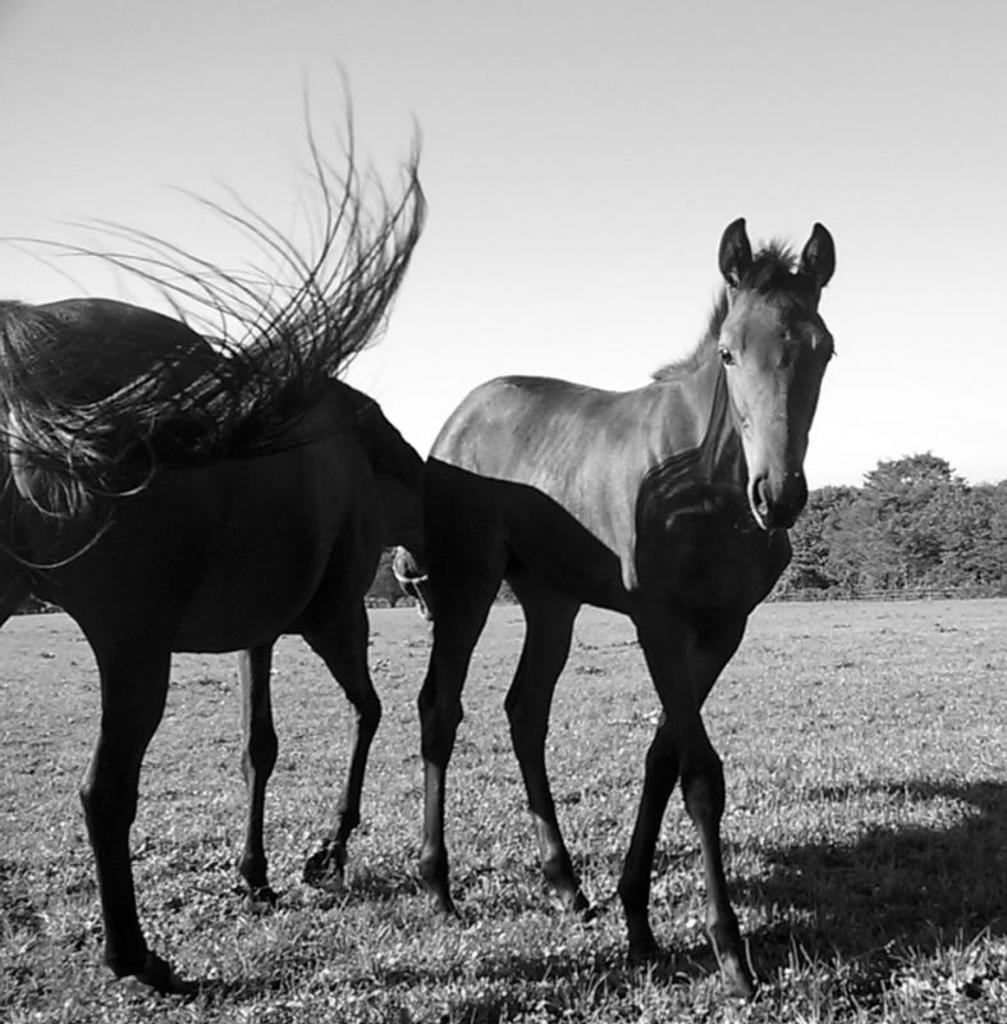What is the color scheme of the image? The image is black and white. What animals are present in the image? There are horses in the image. What type of terrain is visible in the image? There is grass on the ground in the image. What can be seen in the background of the image? There are trees and the sky visible in the background of the image. Can you tell me how many rays are shining on the horses in the image? There are no rays present in the image, as it is black and white and does not depict any light sources. What type of drum can be seen being played by the horses in the image? There are no drums or horse musicians in the image; it features horses in a grassy area with trees and sky in the background. 